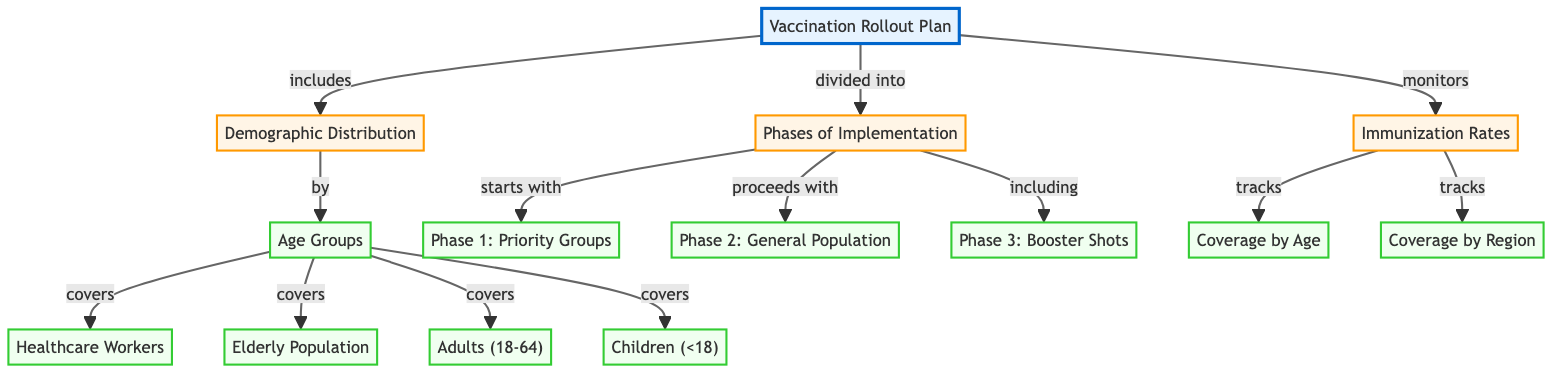What are the main components of the Vaccination Rollout Plan? The main components are Demographic Distribution, Phases of Implementation, and Immunization Rates. These are the three secondary nodes that connect to the main node "Vaccination Rollout Plan."
Answer: Demographic Distribution, Phases of Implementation, Immunization Rates How many age groups are accounted for in the Demographic Distribution? The Demographic Distribution node includes four specific age group nodes: Healthcare Workers, Elderly Population, Adults (18-64), and Children (<18). Thus, the total count is four.
Answer: 4 What is the first phase of the vaccination rollout? The first phase of implementation, as indicated by the node connections, is "Phase 1: Priority Groups." This is the first node listed under the Phases of Implementation section.
Answer: Phase 1: Priority Groups Which node tracks the coverage by age? The node that monitors the coverage by age is labeled "Coverage by Age," which is linked under the Immunization Rates node. This indicates it is specifically for tracking age-related vaccination coverage.
Answer: Coverage by Age What does the diagram indicate happens after Phase 1? After Phase 1, the diagram indicates that the next phase is "Phase 2: General Population." This follows logically in the sequence of implementation phases.
Answer: Phase 2: General Population Which demographic group is the last to be mentioned in the Age Groups section? The last demographic group mentioned under the Age Groups section is "Children (<18)." It is the last connecting node listed under the Demographic Distribution.
Answer: Children (<18) How are the Phases of Implementation structured in the diagram? The Phases of Implementation are structured in a sequence: it starts with Phase 1, proceeds to Phase 2, and includes Phase 3 for Booster Shots. This linear arrangement shows the progression of the rollout plan.
Answer: Phase 1, Phase 2, Phase 3 What phase of the rollout includes monitoring of booster shots? The phase of implementation that includes monitoring of booster shots is labeled "Phase 3: Booster Shots," which is a key part of the sequence of vaccination phases.
Answer: Phase 3: Booster Shots 